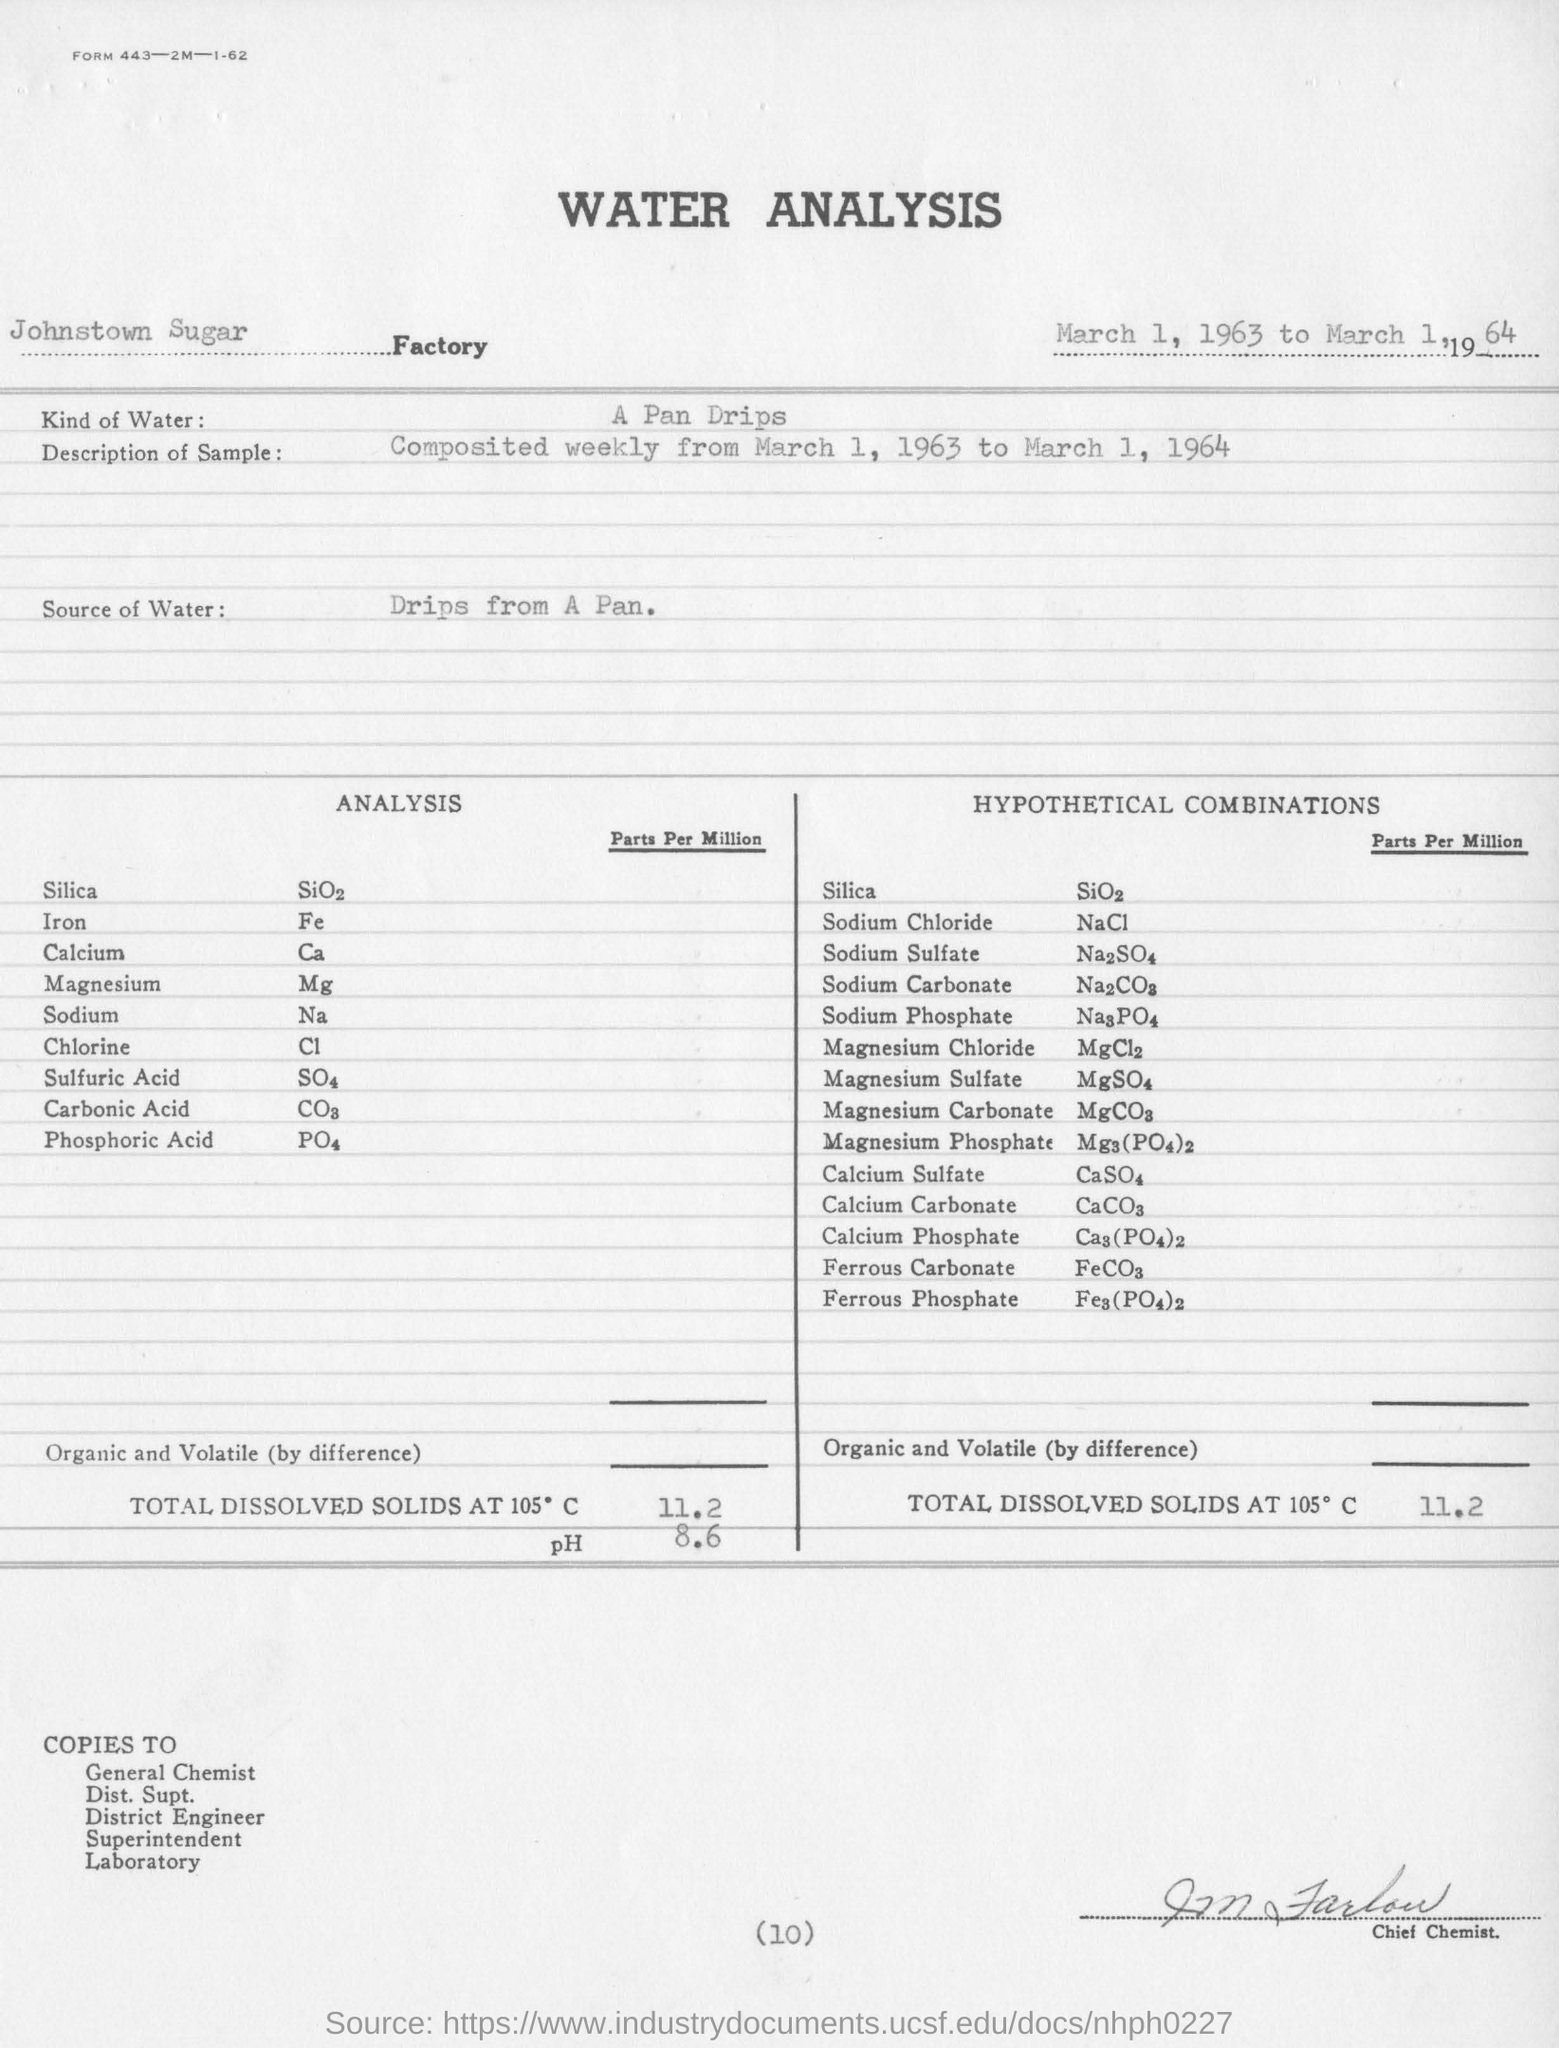What is the chemical formula of Sodium Chloride?
Your response must be concise. NaCl. 